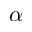Convert formula to latex. <formula><loc_0><loc_0><loc_500><loc_500>\alpha</formula> 